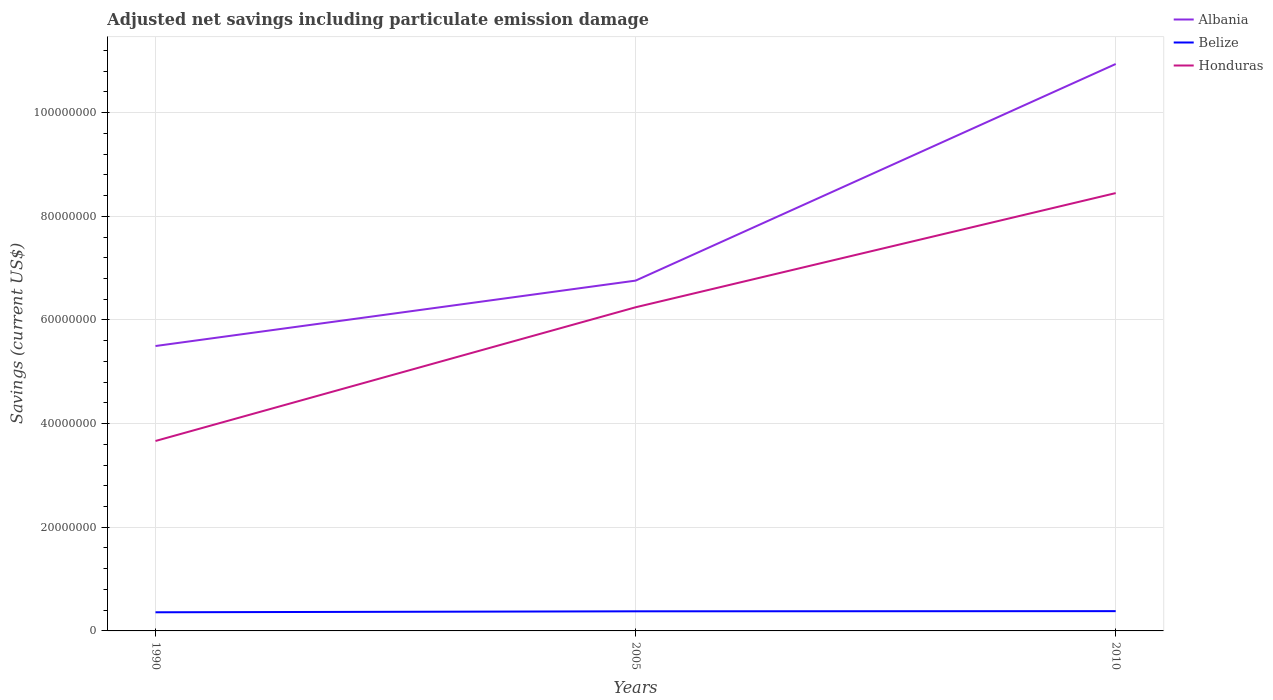Is the number of lines equal to the number of legend labels?
Provide a succinct answer. Yes. Across all years, what is the maximum net savings in Honduras?
Give a very brief answer. 3.66e+07. In which year was the net savings in Belize maximum?
Provide a succinct answer. 1990. What is the total net savings in Albania in the graph?
Provide a succinct answer. -5.44e+07. What is the difference between the highest and the second highest net savings in Albania?
Ensure brevity in your answer.  5.44e+07. What is the difference between the highest and the lowest net savings in Belize?
Make the answer very short. 2. Is the net savings in Honduras strictly greater than the net savings in Belize over the years?
Your response must be concise. No. What is the difference between two consecutive major ticks on the Y-axis?
Your answer should be very brief. 2.00e+07. Does the graph contain any zero values?
Provide a short and direct response. No. Does the graph contain grids?
Offer a very short reply. Yes. What is the title of the graph?
Ensure brevity in your answer.  Adjusted net savings including particulate emission damage. Does "Jordan" appear as one of the legend labels in the graph?
Offer a terse response. No. What is the label or title of the X-axis?
Keep it short and to the point. Years. What is the label or title of the Y-axis?
Provide a short and direct response. Savings (current US$). What is the Savings (current US$) in Albania in 1990?
Keep it short and to the point. 5.50e+07. What is the Savings (current US$) of Belize in 1990?
Offer a very short reply. 3.60e+06. What is the Savings (current US$) in Honduras in 1990?
Make the answer very short. 3.66e+07. What is the Savings (current US$) of Albania in 2005?
Make the answer very short. 6.76e+07. What is the Savings (current US$) in Belize in 2005?
Provide a short and direct response. 3.78e+06. What is the Savings (current US$) of Honduras in 2005?
Make the answer very short. 6.24e+07. What is the Savings (current US$) in Albania in 2010?
Provide a succinct answer. 1.09e+08. What is the Savings (current US$) of Belize in 2010?
Give a very brief answer. 3.82e+06. What is the Savings (current US$) in Honduras in 2010?
Provide a succinct answer. 8.45e+07. Across all years, what is the maximum Savings (current US$) of Albania?
Make the answer very short. 1.09e+08. Across all years, what is the maximum Savings (current US$) in Belize?
Ensure brevity in your answer.  3.82e+06. Across all years, what is the maximum Savings (current US$) in Honduras?
Offer a very short reply. 8.45e+07. Across all years, what is the minimum Savings (current US$) of Albania?
Your response must be concise. 5.50e+07. Across all years, what is the minimum Savings (current US$) of Belize?
Give a very brief answer. 3.60e+06. Across all years, what is the minimum Savings (current US$) of Honduras?
Your answer should be compact. 3.66e+07. What is the total Savings (current US$) of Albania in the graph?
Your answer should be compact. 2.32e+08. What is the total Savings (current US$) in Belize in the graph?
Offer a terse response. 1.12e+07. What is the total Savings (current US$) in Honduras in the graph?
Your answer should be very brief. 1.84e+08. What is the difference between the Savings (current US$) in Albania in 1990 and that in 2005?
Provide a succinct answer. -1.26e+07. What is the difference between the Savings (current US$) in Belize in 1990 and that in 2005?
Give a very brief answer. -1.86e+05. What is the difference between the Savings (current US$) in Honduras in 1990 and that in 2005?
Provide a short and direct response. -2.58e+07. What is the difference between the Savings (current US$) of Albania in 1990 and that in 2010?
Keep it short and to the point. -5.44e+07. What is the difference between the Savings (current US$) in Belize in 1990 and that in 2010?
Provide a short and direct response. -2.20e+05. What is the difference between the Savings (current US$) of Honduras in 1990 and that in 2010?
Keep it short and to the point. -4.78e+07. What is the difference between the Savings (current US$) in Albania in 2005 and that in 2010?
Provide a short and direct response. -4.18e+07. What is the difference between the Savings (current US$) of Belize in 2005 and that in 2010?
Your answer should be very brief. -3.43e+04. What is the difference between the Savings (current US$) in Honduras in 2005 and that in 2010?
Provide a succinct answer. -2.20e+07. What is the difference between the Savings (current US$) in Albania in 1990 and the Savings (current US$) in Belize in 2005?
Your response must be concise. 5.12e+07. What is the difference between the Savings (current US$) in Albania in 1990 and the Savings (current US$) in Honduras in 2005?
Offer a very short reply. -7.48e+06. What is the difference between the Savings (current US$) in Belize in 1990 and the Savings (current US$) in Honduras in 2005?
Give a very brief answer. -5.88e+07. What is the difference between the Savings (current US$) of Albania in 1990 and the Savings (current US$) of Belize in 2010?
Keep it short and to the point. 5.12e+07. What is the difference between the Savings (current US$) of Albania in 1990 and the Savings (current US$) of Honduras in 2010?
Keep it short and to the point. -2.95e+07. What is the difference between the Savings (current US$) of Belize in 1990 and the Savings (current US$) of Honduras in 2010?
Give a very brief answer. -8.09e+07. What is the difference between the Savings (current US$) in Albania in 2005 and the Savings (current US$) in Belize in 2010?
Your answer should be very brief. 6.38e+07. What is the difference between the Savings (current US$) of Albania in 2005 and the Savings (current US$) of Honduras in 2010?
Provide a succinct answer. -1.69e+07. What is the difference between the Savings (current US$) of Belize in 2005 and the Savings (current US$) of Honduras in 2010?
Provide a succinct answer. -8.07e+07. What is the average Savings (current US$) in Albania per year?
Offer a very short reply. 7.73e+07. What is the average Savings (current US$) of Belize per year?
Your answer should be very brief. 3.73e+06. What is the average Savings (current US$) in Honduras per year?
Your response must be concise. 6.12e+07. In the year 1990, what is the difference between the Savings (current US$) of Albania and Savings (current US$) of Belize?
Provide a short and direct response. 5.14e+07. In the year 1990, what is the difference between the Savings (current US$) of Albania and Savings (current US$) of Honduras?
Offer a terse response. 1.83e+07. In the year 1990, what is the difference between the Savings (current US$) of Belize and Savings (current US$) of Honduras?
Keep it short and to the point. -3.30e+07. In the year 2005, what is the difference between the Savings (current US$) of Albania and Savings (current US$) of Belize?
Give a very brief answer. 6.38e+07. In the year 2005, what is the difference between the Savings (current US$) in Albania and Savings (current US$) in Honduras?
Your answer should be very brief. 5.14e+06. In the year 2005, what is the difference between the Savings (current US$) in Belize and Savings (current US$) in Honduras?
Offer a terse response. -5.87e+07. In the year 2010, what is the difference between the Savings (current US$) in Albania and Savings (current US$) in Belize?
Provide a succinct answer. 1.06e+08. In the year 2010, what is the difference between the Savings (current US$) in Albania and Savings (current US$) in Honduras?
Offer a very short reply. 2.49e+07. In the year 2010, what is the difference between the Savings (current US$) in Belize and Savings (current US$) in Honduras?
Provide a succinct answer. -8.07e+07. What is the ratio of the Savings (current US$) in Albania in 1990 to that in 2005?
Offer a very short reply. 0.81. What is the ratio of the Savings (current US$) in Belize in 1990 to that in 2005?
Offer a very short reply. 0.95. What is the ratio of the Savings (current US$) in Honduras in 1990 to that in 2005?
Your answer should be compact. 0.59. What is the ratio of the Savings (current US$) in Albania in 1990 to that in 2010?
Your response must be concise. 0.5. What is the ratio of the Savings (current US$) in Belize in 1990 to that in 2010?
Give a very brief answer. 0.94. What is the ratio of the Savings (current US$) of Honduras in 1990 to that in 2010?
Your response must be concise. 0.43. What is the ratio of the Savings (current US$) in Albania in 2005 to that in 2010?
Your answer should be compact. 0.62. What is the ratio of the Savings (current US$) of Honduras in 2005 to that in 2010?
Give a very brief answer. 0.74. What is the difference between the highest and the second highest Savings (current US$) in Albania?
Your answer should be compact. 4.18e+07. What is the difference between the highest and the second highest Savings (current US$) of Belize?
Give a very brief answer. 3.43e+04. What is the difference between the highest and the second highest Savings (current US$) of Honduras?
Provide a succinct answer. 2.20e+07. What is the difference between the highest and the lowest Savings (current US$) in Albania?
Provide a short and direct response. 5.44e+07. What is the difference between the highest and the lowest Savings (current US$) of Belize?
Provide a short and direct response. 2.20e+05. What is the difference between the highest and the lowest Savings (current US$) in Honduras?
Offer a very short reply. 4.78e+07. 